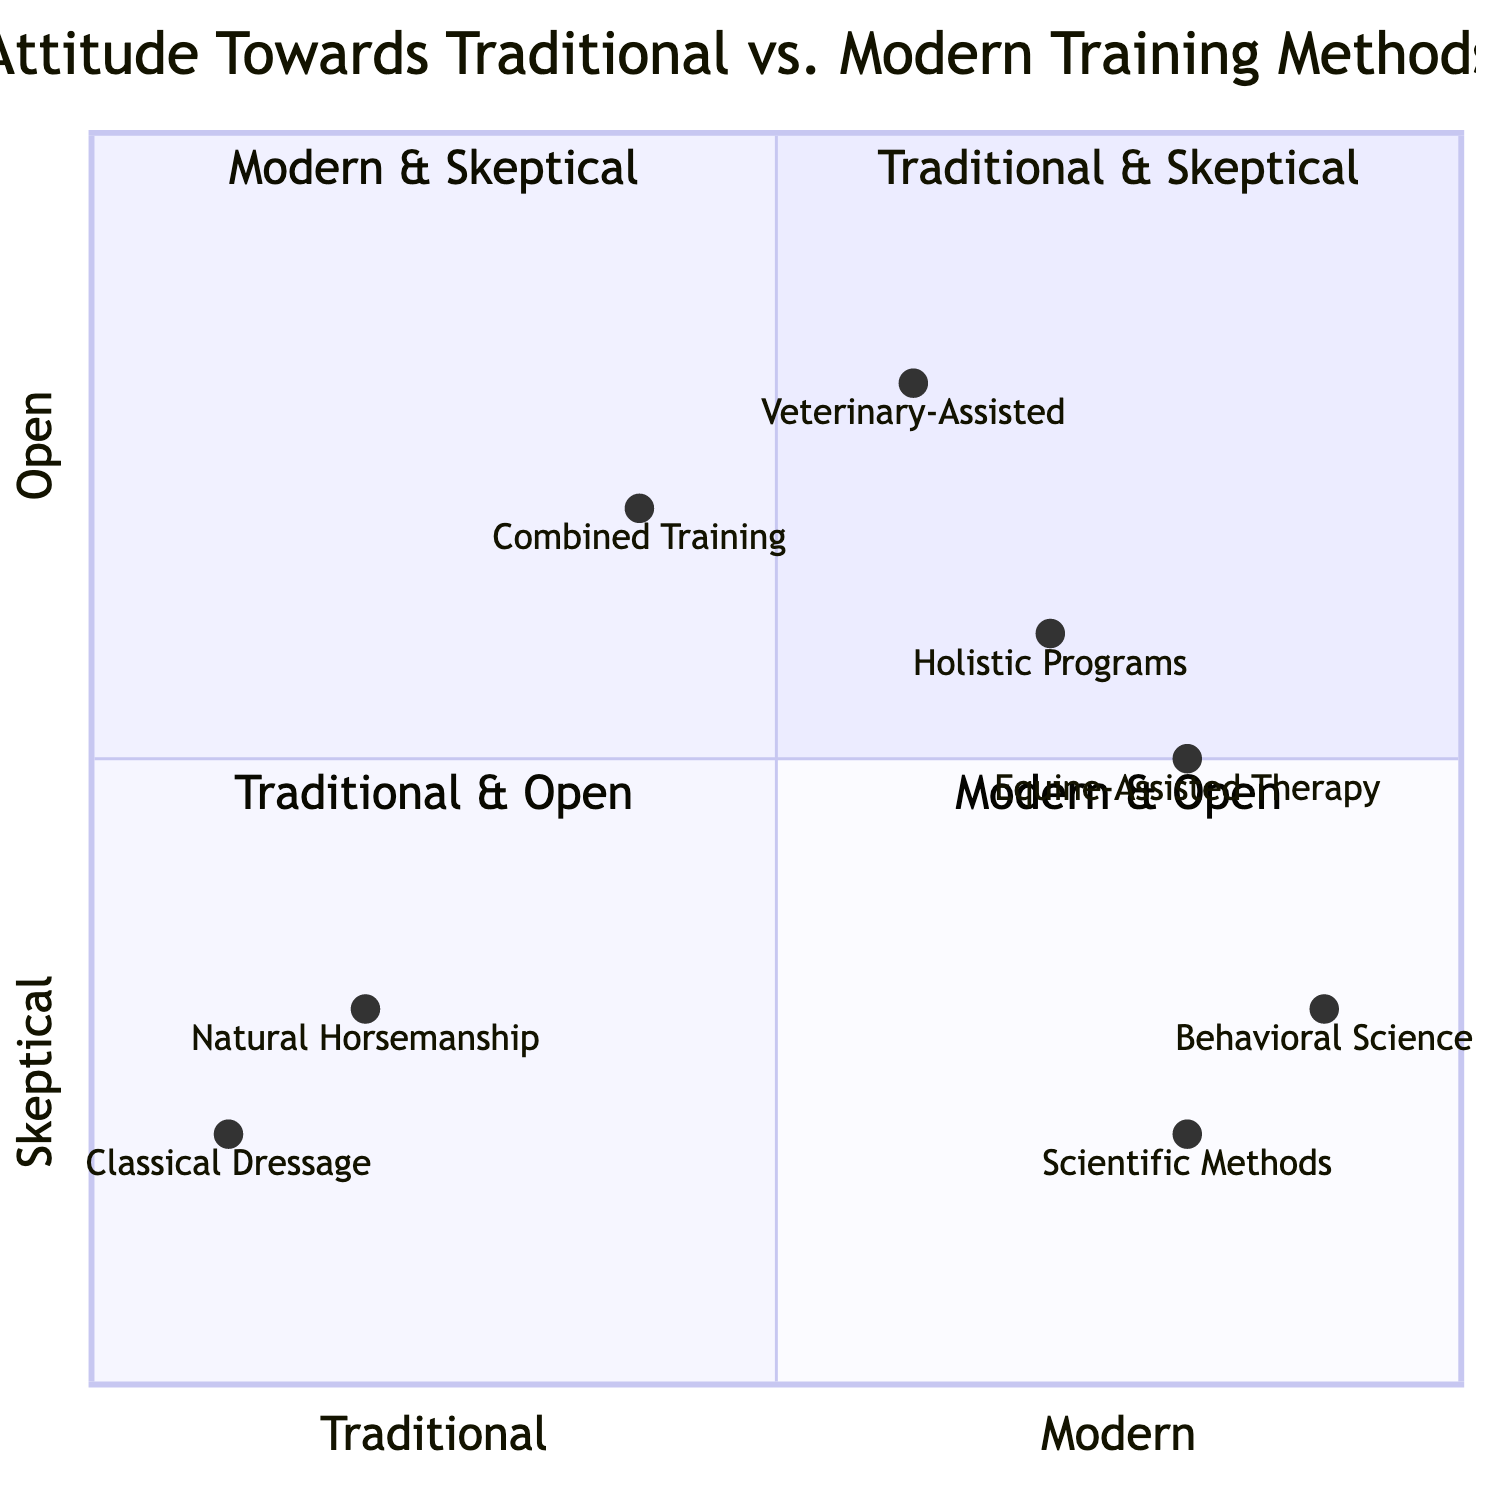What quadrant is "Natural Horsemanship" located in? "Natural Horsemanship" is positioned in the first quadrant, which is labeled "Traditional Approaches/Skeptical of Modern Methods." Therefore, its quadrant is identified explicitly in the diagram.
Answer: Traditional Approaches/Skeptical of Modern Methods Which training method is the most skeptical of traditional approaches? Among the training methods represented in the quadrants, "Scientific Training Methods," located in the second quadrant, showcases a skeptical attitude towards traditional methods, based on its positioning in the diagram.
Answer: Scientific Training Methods How many methods are included in the "Modern Approaches/Inclusive of Traditional Methods" quadrant? The quadrant labeled "Modern Approaches/Inclusive of Traditional Methods" contains two training methods, which are "Holistic Training Programs" and "Equine-Assisted Therapy (Skeptical Perspective)." Thus, the count of methods located in this quadrant is two.
Answer: 2 What characterizes "Combined Training with Modern Techniques"? The characteristics of "Combined Training with Modern Techniques" include blending traditional groundwork with advanced tools and incorporating positive reinforcement strategies. This information can be directly found in its respective quadrant with its attributes listed.
Answer: Blending traditional groundwork with advanced tools, incorporating positive reinforcement strategies Which quadrant has the method "Veterinary-Assisted Training"? The "Veterinary-Assisted Training" method is situated in the third quadrant, which is titled "Traditional Approaches/Open to Modern Methods." This is confirmed by its coordinates within the diagram that place it in that specific quadrant.
Answer: Traditional Approaches/Open to Modern Methods Which methods are found in the "Modern Approaches/Skeptical of Traditional Methods" quadrant? The "Modern Approaches/Skeptical of Traditional Methods" quadrant contains two methods: "Scientific Training Methods" and "Behavioral Science-Based Training." By examining the quadrant's content, both methods can be clearly identified as part of that grouping.
Answer: Scientific Training Methods, Behavioral Science-Based Training What is the focus of "Equine-Assisted Therapy"? "Equine-Assisted Therapy," as characterized in the diagram, uses horses as facilitators for human therapy and is noted as controversial and lacking rigorous scientific validation. This description is provided alongside its name in the quadrant.
Answer: Use of horses as facilitators for human therapy, controversial and lacking rigorous scientific validation How does "Holistic Training Programs" combine methodologies? "Holistic Training Programs" combine modern science with traditional horsemanship while emphasizing overall health and mental well-being. This blend can be identified in the quadrant's description specific to this method.
Answer: Combines modern science with traditional horsemanship, emphasizes overall health and mental well-being 